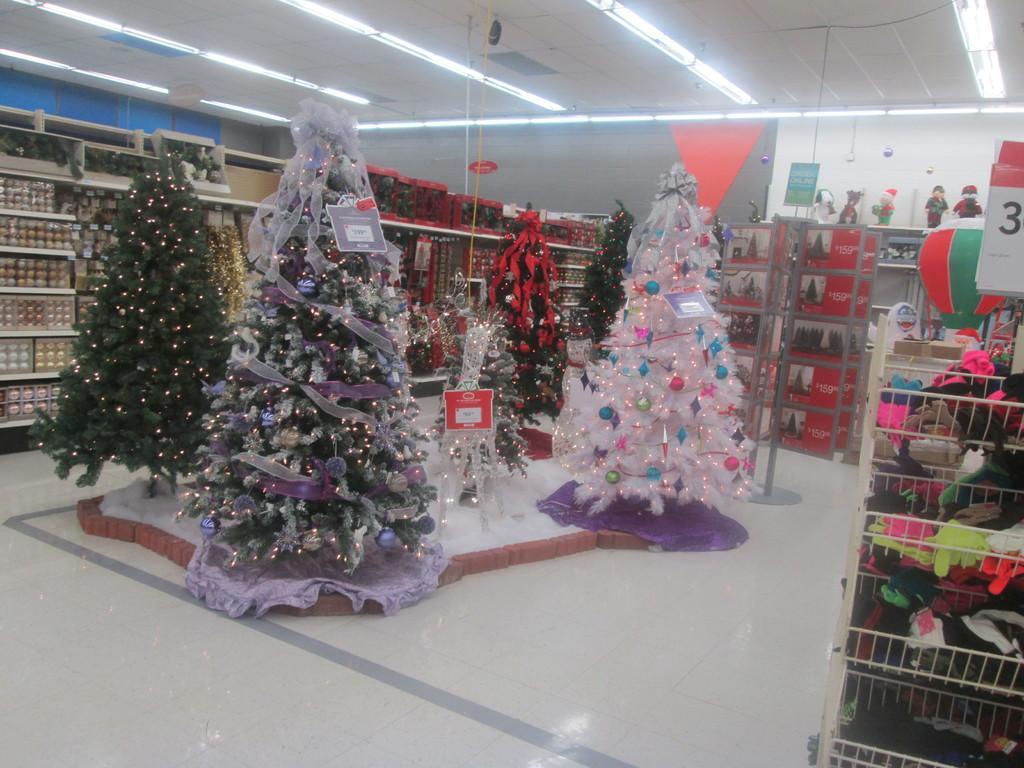In one or two sentences, can you explain what this image depicts? In this image there are Christmas trees visible on the floor, in which there are decorative items and lighting visible , on the right side there is a rack , on which there are some clothes, at the top there is a roof, on which there are some lights visible, in the middle there are some racks in which there are some food items visible, on top of of rack I can see some dolls on the right side. 